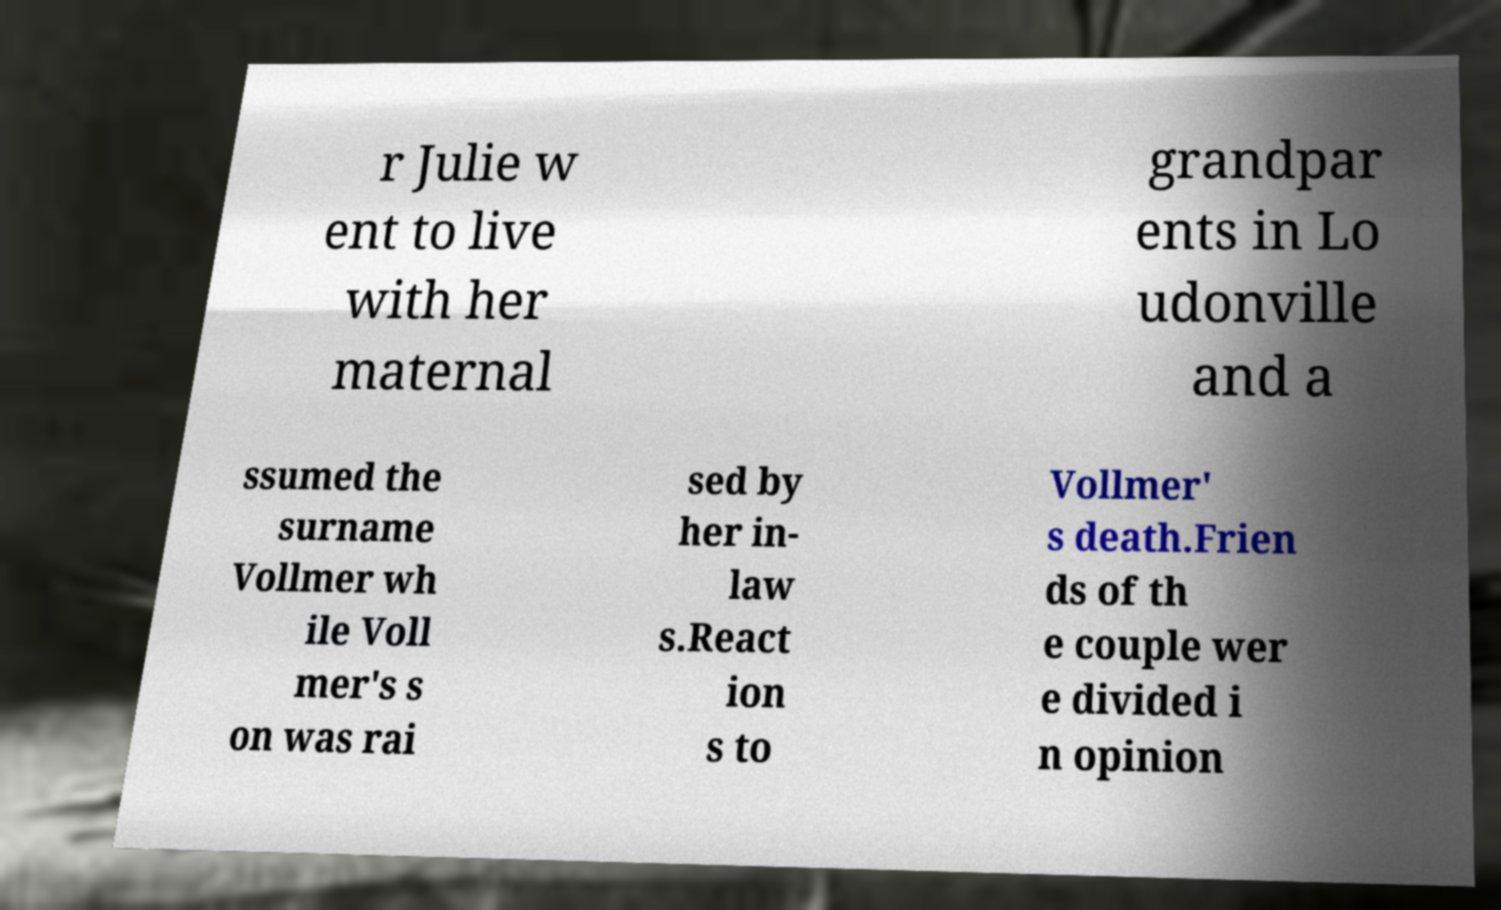What messages or text are displayed in this image? I need them in a readable, typed format. r Julie w ent to live with her maternal grandpar ents in Lo udonville and a ssumed the surname Vollmer wh ile Voll mer's s on was rai sed by her in- law s.React ion s to Vollmer' s death.Frien ds of th e couple wer e divided i n opinion 